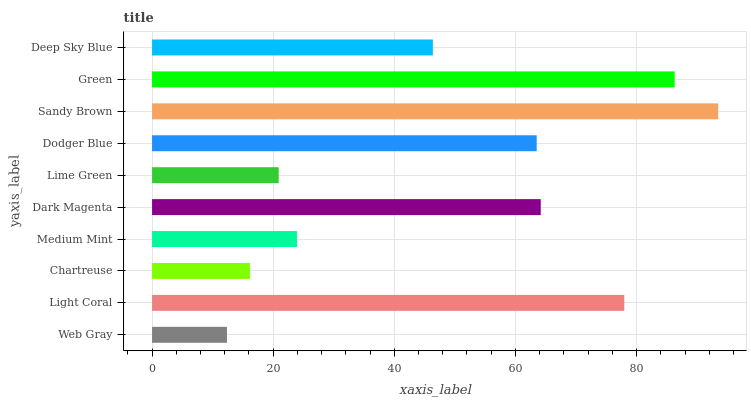Is Web Gray the minimum?
Answer yes or no. Yes. Is Sandy Brown the maximum?
Answer yes or no. Yes. Is Light Coral the minimum?
Answer yes or no. No. Is Light Coral the maximum?
Answer yes or no. No. Is Light Coral greater than Web Gray?
Answer yes or no. Yes. Is Web Gray less than Light Coral?
Answer yes or no. Yes. Is Web Gray greater than Light Coral?
Answer yes or no. No. Is Light Coral less than Web Gray?
Answer yes or no. No. Is Dodger Blue the high median?
Answer yes or no. Yes. Is Deep Sky Blue the low median?
Answer yes or no. Yes. Is Dark Magenta the high median?
Answer yes or no. No. Is Dark Magenta the low median?
Answer yes or no. No. 